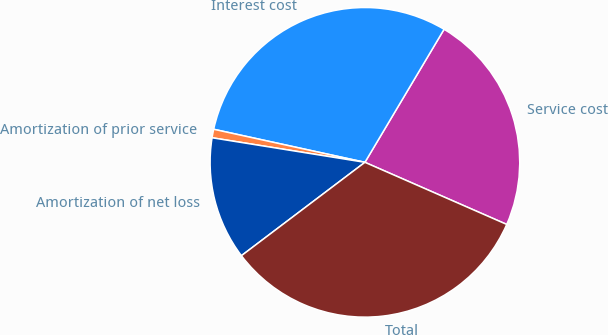Convert chart to OTSL. <chart><loc_0><loc_0><loc_500><loc_500><pie_chart><fcel>Service cost<fcel>Interest cost<fcel>Amortization of prior service<fcel>Amortization of net loss<fcel>Total<nl><fcel>23.03%<fcel>30.12%<fcel>0.89%<fcel>12.84%<fcel>33.13%<nl></chart> 